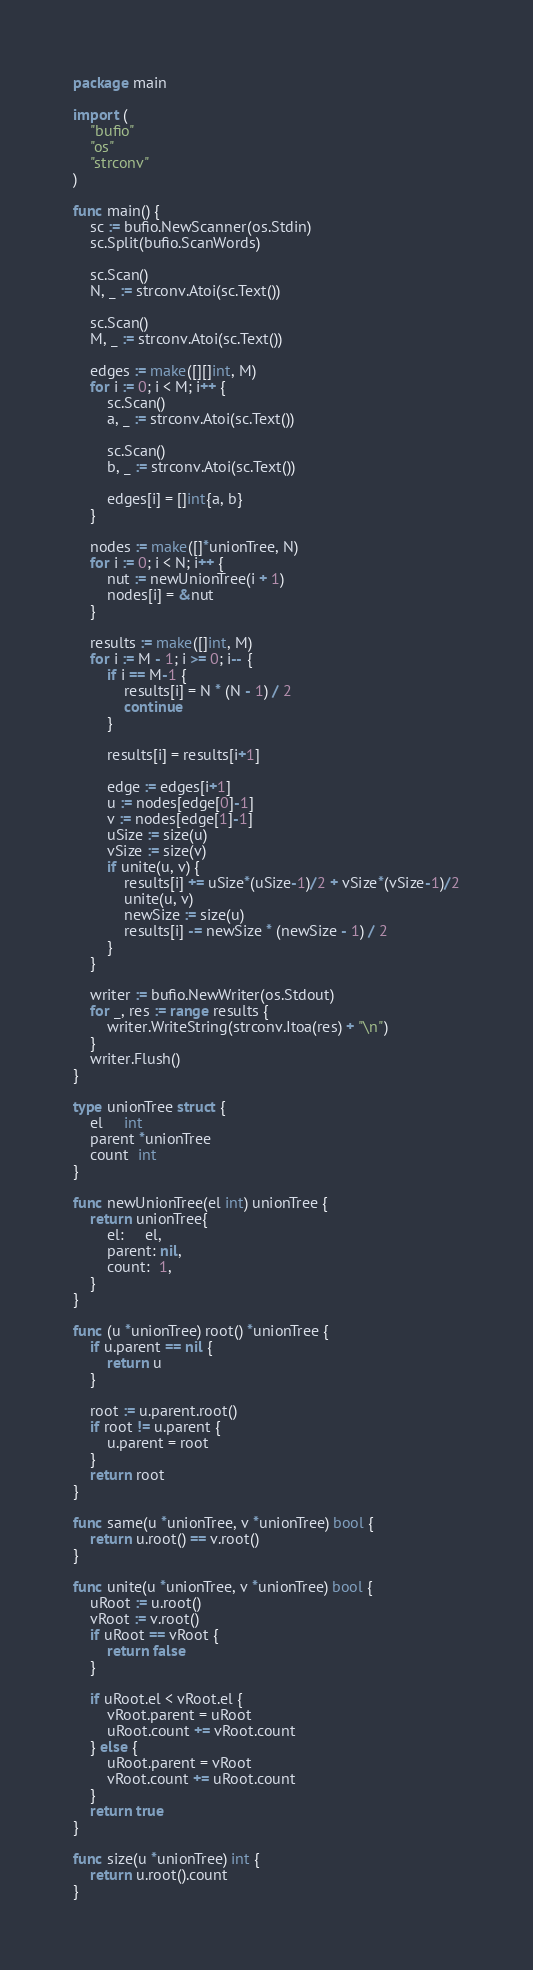<code> <loc_0><loc_0><loc_500><loc_500><_Go_>package main

import (
	"bufio"
	"os"
	"strconv"
)

func main() {
	sc := bufio.NewScanner(os.Stdin)
	sc.Split(bufio.ScanWords)

	sc.Scan()
	N, _ := strconv.Atoi(sc.Text())

	sc.Scan()
	M, _ := strconv.Atoi(sc.Text())

	edges := make([][]int, M)
	for i := 0; i < M; i++ {
		sc.Scan()
		a, _ := strconv.Atoi(sc.Text())

		sc.Scan()
		b, _ := strconv.Atoi(sc.Text())

		edges[i] = []int{a, b}
	}

	nodes := make([]*unionTree, N)
	for i := 0; i < N; i++ {
		nut := newUnionTree(i + 1)
		nodes[i] = &nut
	}

	results := make([]int, M)
	for i := M - 1; i >= 0; i-- {
		if i == M-1 {
			results[i] = N * (N - 1) / 2
			continue
		}

		results[i] = results[i+1]

		edge := edges[i+1]
		u := nodes[edge[0]-1]
		v := nodes[edge[1]-1]
		uSize := size(u)
		vSize := size(v)
		if unite(u, v) {
			results[i] += uSize*(uSize-1)/2 + vSize*(vSize-1)/2
			unite(u, v)
			newSize := size(u)
			results[i] -= newSize * (newSize - 1) / 2
		}
	}

	writer := bufio.NewWriter(os.Stdout)
	for _, res := range results {
		writer.WriteString(strconv.Itoa(res) + "\n")
	}
	writer.Flush()
}

type unionTree struct {
	el     int
	parent *unionTree
	count  int
}

func newUnionTree(el int) unionTree {
	return unionTree{
		el:     el,
		parent: nil,
		count:  1,
	}
}

func (u *unionTree) root() *unionTree {
	if u.parent == nil {
		return u
	}

	root := u.parent.root()
	if root != u.parent {
		u.parent = root
	}
	return root
}

func same(u *unionTree, v *unionTree) bool {
	return u.root() == v.root()
}

func unite(u *unionTree, v *unionTree) bool {
	uRoot := u.root()
	vRoot := v.root()
	if uRoot == vRoot {
		return false
	}

	if uRoot.el < vRoot.el {
		vRoot.parent = uRoot
		uRoot.count += vRoot.count
	} else {
		uRoot.parent = vRoot
		vRoot.count += uRoot.count
	}
	return true
}

func size(u *unionTree) int {
	return u.root().count
}
</code> 